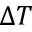<formula> <loc_0><loc_0><loc_500><loc_500>\Delta T</formula> 